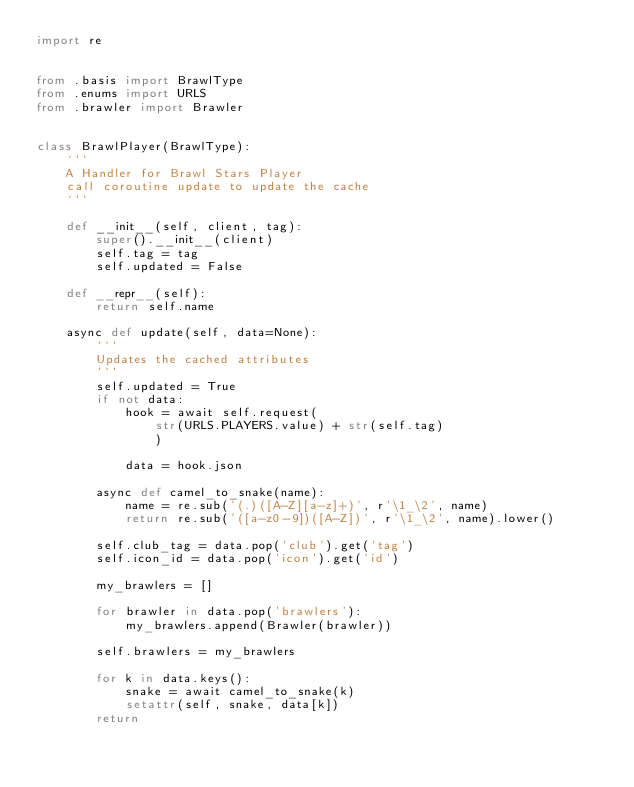<code> <loc_0><loc_0><loc_500><loc_500><_Python_>import re


from .basis import BrawlType
from .enums import URLS
from .brawler import Brawler


class BrawlPlayer(BrawlType):
    '''
    A Handler for Brawl Stars Player
    call coroutine update to update the cache
    '''

    def __init__(self, client, tag):
        super().__init__(client)
        self.tag = tag
        self.updated = False

    def __repr__(self):
        return self.name

    async def update(self, data=None):
        '''
        Updates the cached attributes
        '''
        self.updated = True
        if not data:
            hook = await self.request(
                str(URLS.PLAYERS.value) + str(self.tag)
                )

            data = hook.json

        async def camel_to_snake(name):
            name = re.sub('(.)([A-Z][a-z]+)', r'\1_\2', name)
            return re.sub('([a-z0-9])([A-Z])', r'\1_\2', name).lower()
   
        self.club_tag = data.pop('club').get('tag')
        self.icon_id = data.pop('icon').get('id')

        my_brawlers = []

        for brawler in data.pop('brawlers'):
            my_brawlers.append(Brawler(brawler))

        self.brawlers = my_brawlers

        for k in data.keys():
            snake = await camel_to_snake(k)
            setattr(self, snake, data[k])
        return
        </code> 